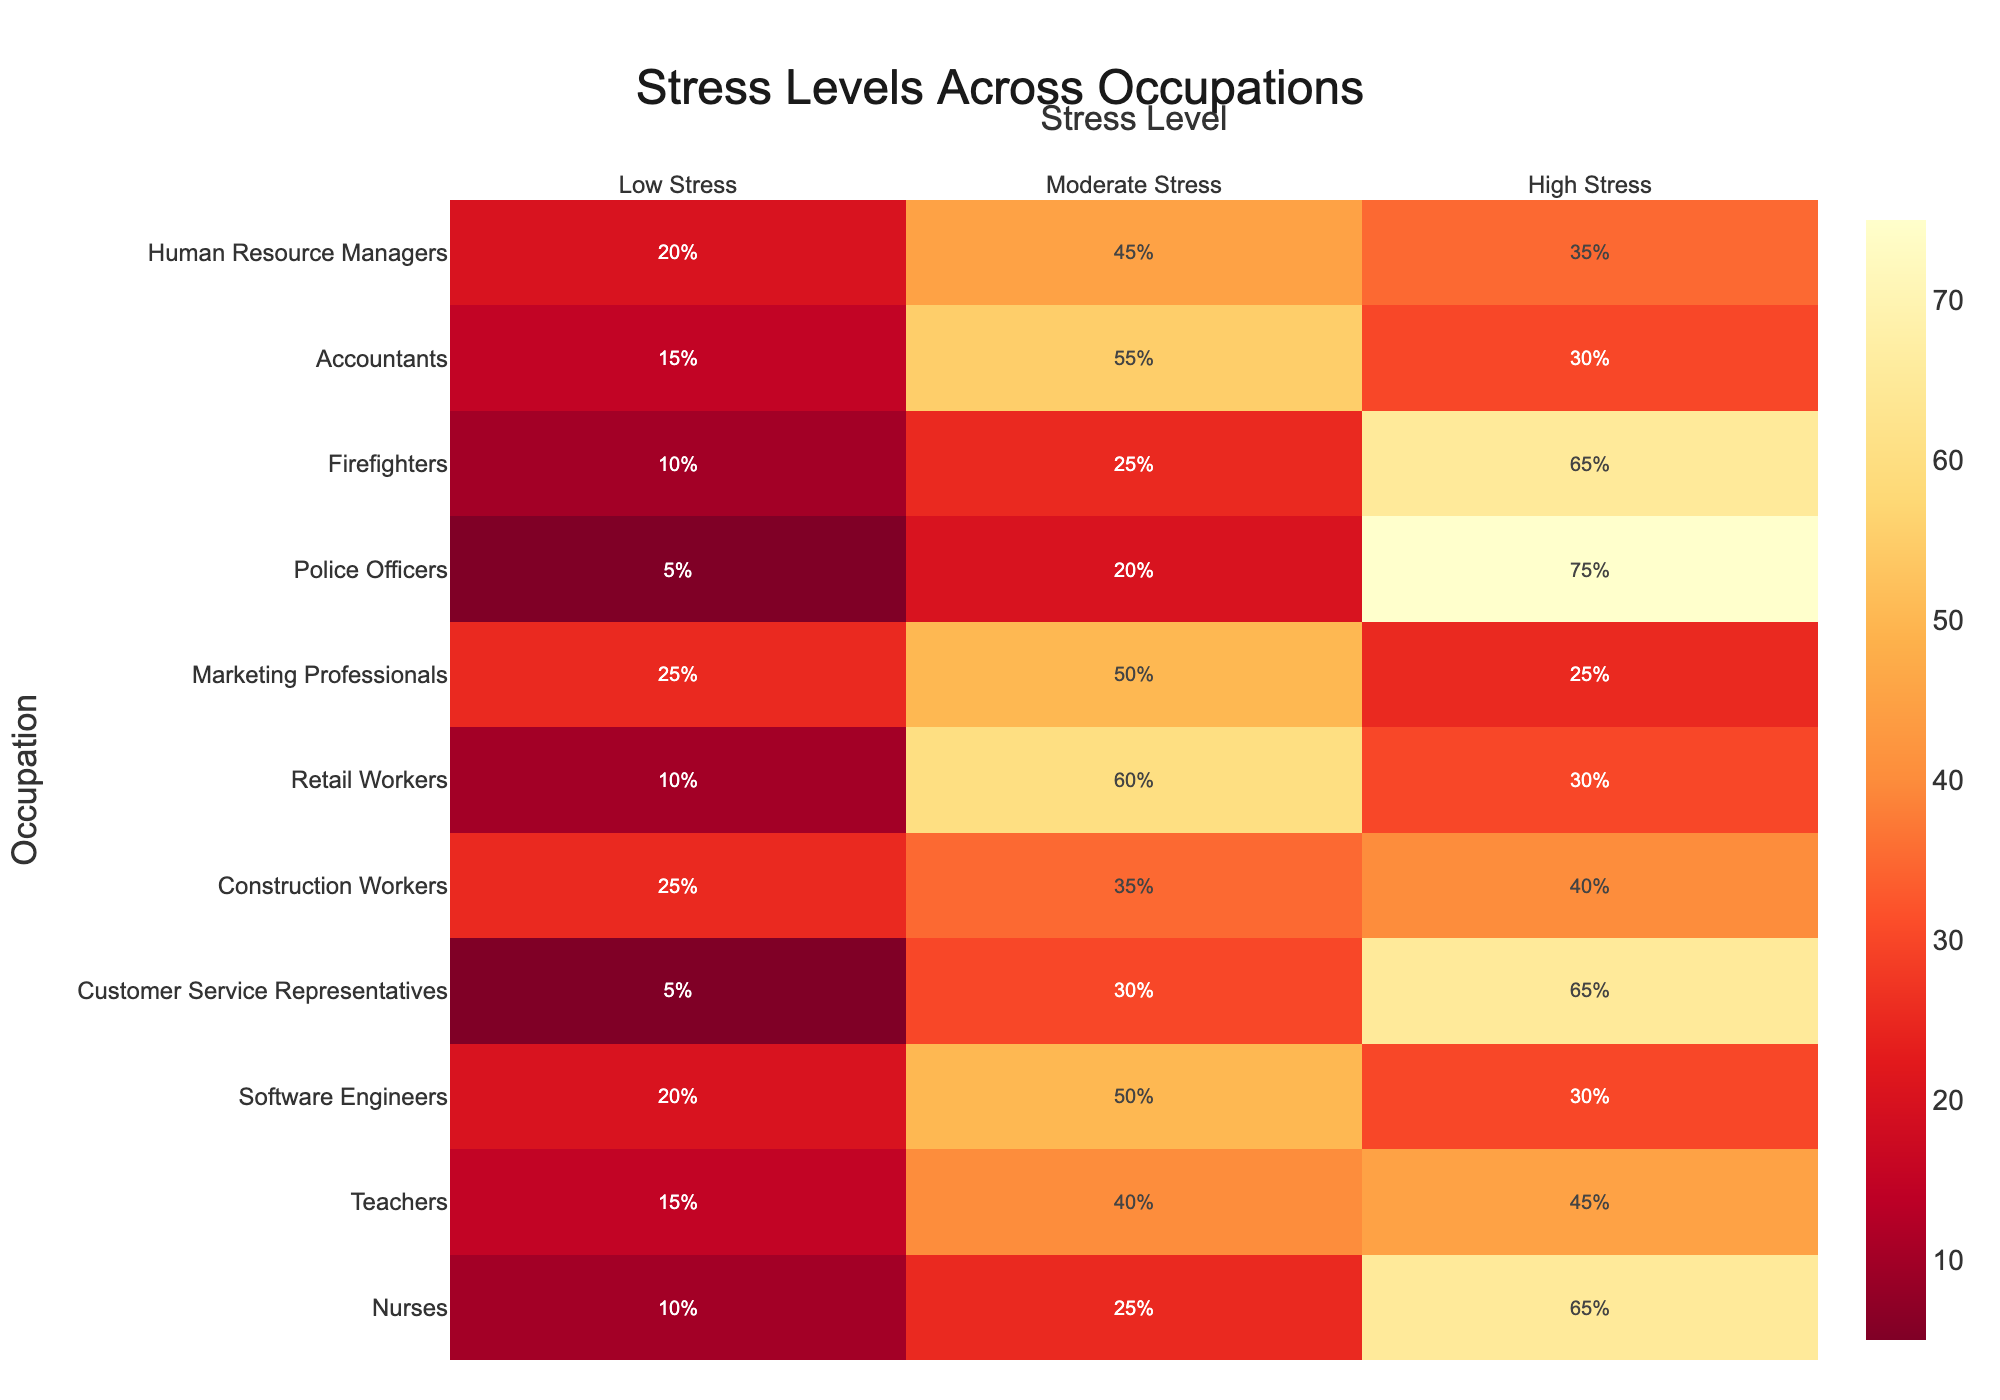What is the title of the figure? The title is typically placed at the top of the figure and directly describes the content of the visualization. Here, the title is written in a prominent font at the top center of the plot.
Answer: Stress Levels Across Occupations Which occupation experiences the highest percentage of high stress? To determine this, look at the 'High Stress' column and identify the occupation with the highest percentage value. Comparing all values, 'Police Officers' have the highest with 75%.
Answer: Police Officers What is the lowest percentage of low stress observed, and which occupation does it correspond to? By examining the 'Low Stress' column, identify the smallest percentage. The smallest value is 5%, which corresponds to 'Customer Service Representatives' and 'Police Officers'.
Answer: 5%, Customer Service Representatives and Police Officers Which occupation has the most balanced distribution of stress levels? A balanced distribution would mean the percentages in 'Low Stress', 'Moderate Stress', and 'High Stress' are relatively close to each other. 'Construction Workers' have values (25, 35, 40), which are closer to each other compared to others.
Answer: Construction Workers For which occupation does moderate stress constitute the majority? Look at the 'Moderate Stress' column and identify if the value is more than 50%. 'Retail Workers' with 60% is the example where moderate stress forms the majority.
Answer: Retail Workers How does the stress level distribution for Nurses compare to that of Firefighters? Comparing the values for 'Nurses' (10, 25, 65) and 'Firefighters' (10, 25, 65) shows identical distributions across all stress levels for both occupations.
Answer: Identical What is the average percentage of high stress across all occupations? Sum the 'High Stress' percentages for all occupations and divide by the number of occupations. The total is 65+45+30+65+40+30+25+75+65+30+35 = 505. Divided by 11 occupations, the average is 505/11 ≈ 45.91.
Answer: ≈ 45.91% Which occupation has the highest percentage in any single stress level category? To find this, identify the highest percentages across all three stress levels columns. 'Police Officers' have the highest single value with 75% in 'High Stress'.
Answer: Police Officers What is the total percentage of low stress for Nurses and Teachers combined? Add the 'Low Stress' percentages for 'Nurses' and 'Teachers', which are 10 and 15 respectively, resulting in a sum of 10 + 15 = 25%.
Answer: 25% Is the percentage of moderate stress higher in Software Engineers or Human Resource Managers? Compare the values in the 'Moderate Stress' column. For 'Software Engineers' it's 50% and for 'Human Resource Managers' it's 45%. 'Software Engineers' have the higher percentage.
Answer: Software Engineers 